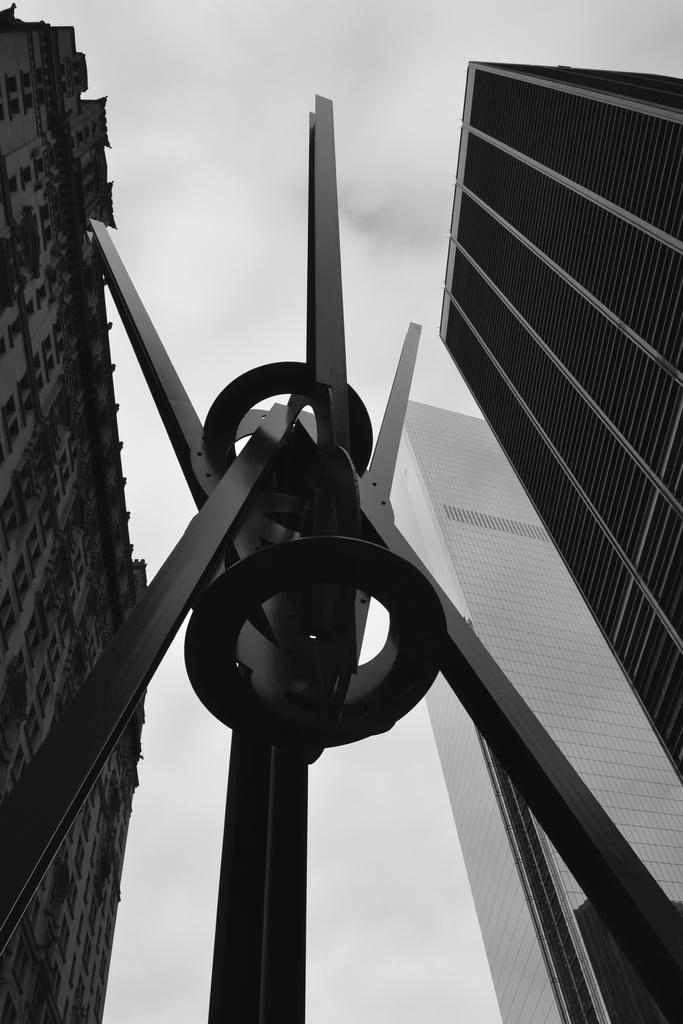What type of picture is in the image? The image contains a black and white picture. What is the color and material of the structure in the picture? The structure is black colored and made of metal. What else can be seen in the picture besides the structure? There are buildings in the picture. What is visible in the background of the picture? The sky is visible in the background of the picture. What type of quarter is visible in the picture? There is no quarter present in the picture. What kind of iron is being used to create the structure in the picture? The structure is made of black colored metal, but the specific type of metal (such as iron) is not mentioned in the facts. 